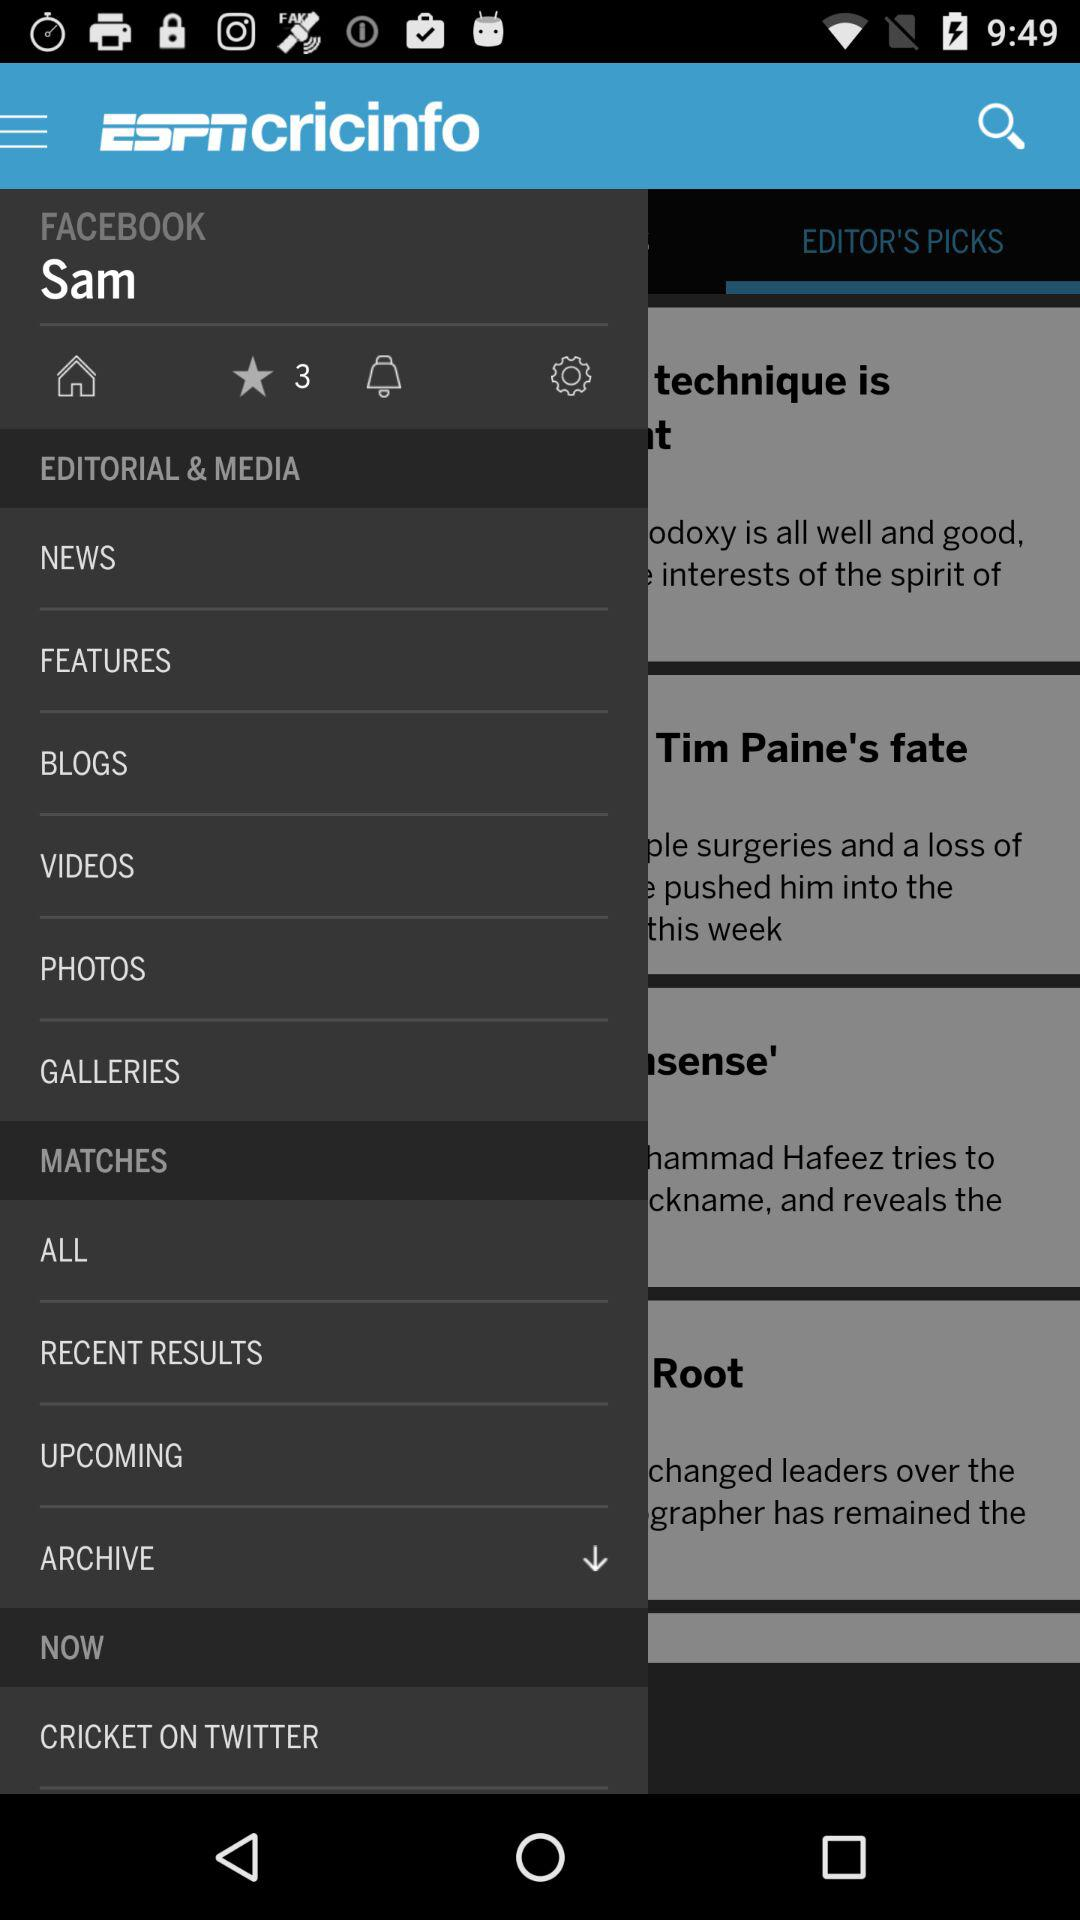What is the name of the application? The name of the application is "ESPNcricinfo". 